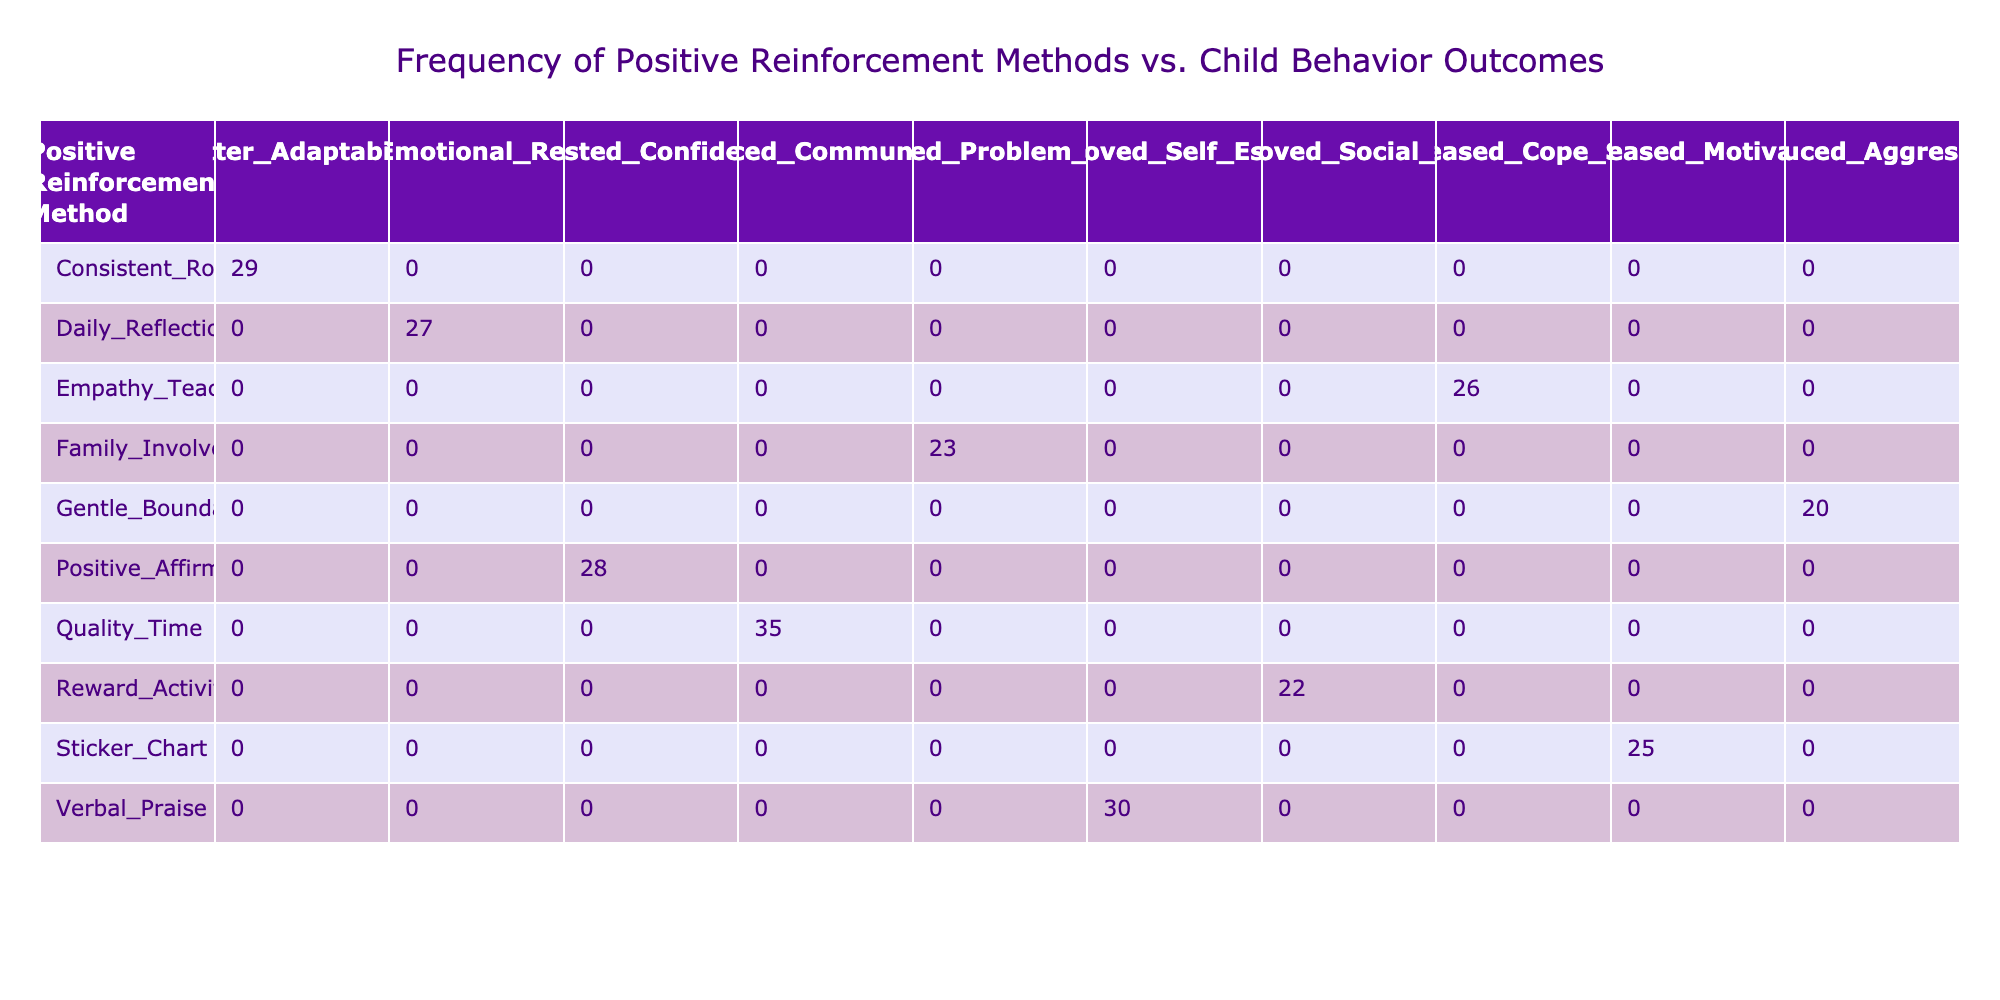What is the frequency of the Verbal Praise method? Referring to the table, under the "Positive Reinforcement Method" column, we find "Verbal Praise" listed. The corresponding "Frequency" value is 30.
Answer: 30 Which child behavior outcome has the highest frequency associated with a positive reinforcement method? Reviewing the "Child Behavior Outcome" column, we look for the highest frequency value. "Quality Time" with "Enhanced Communication" has the highest frequency of 35.
Answer: Enhanced Communication What is the total frequency for all methods of positive reinforcement? To find the total frequency, we add up all the values in the "Frequency" column: 30 + 25 + 35 + 20 + 28 + 22 + 27 + 23 + 29 + 26 = 265.
Answer: 265 Is there a child behavior outcome that does not have any positive reinforcement method associated with it? By checking each behavior outcome listed in the table, all outcomes have at least one corresponding positive reinforcement method, confirming no outcomes are unassociated.
Answer: No What is the average frequency of positive reinforcement methods that lead to improved social skills and enhanced communication? For improved social skills (22 from "Reward Activities") and enhanced communication (35 from "Quality Time"), we calculate the average: (22 + 35) / 2 = 28.5.
Answer: 28.5 Which positive reinforcement method is associated with reduced aggression? Looking at the "Positive Reinforcement Method" column, we find "Gentle Boundaries" listed next to "Reduced Aggression."
Answer: Gentle Boundaries What is the difference in frequency between the most and least frequently used positive reinforcement methods? "Quality Time" has the highest frequency at 35, and "Gentle Boundaries" has the lowest at 20. The difference is 35 - 20 = 15.
Answer: 15 Which two methods have a frequency value within 3 of each other? Checking the frequency values, "Daily Reflection" (27) and "Empathy Teaching" (26) are within 1 of each other, and "Positive Affirmation" (28) and "Daily Reflection" (27) are within 1 as well.
Answer: Daily Reflection and Empathy Teaching How many methods provide a frequency greater than 25? From the "Frequency" column, we observe the methods whose frequencies are greater than 25: Verbal Praise (30), Quality Time (35), Positive Affirmation (28), Daily Reflection (27), and Consistent Routines (29) totaling 5 methods.
Answer: 5 